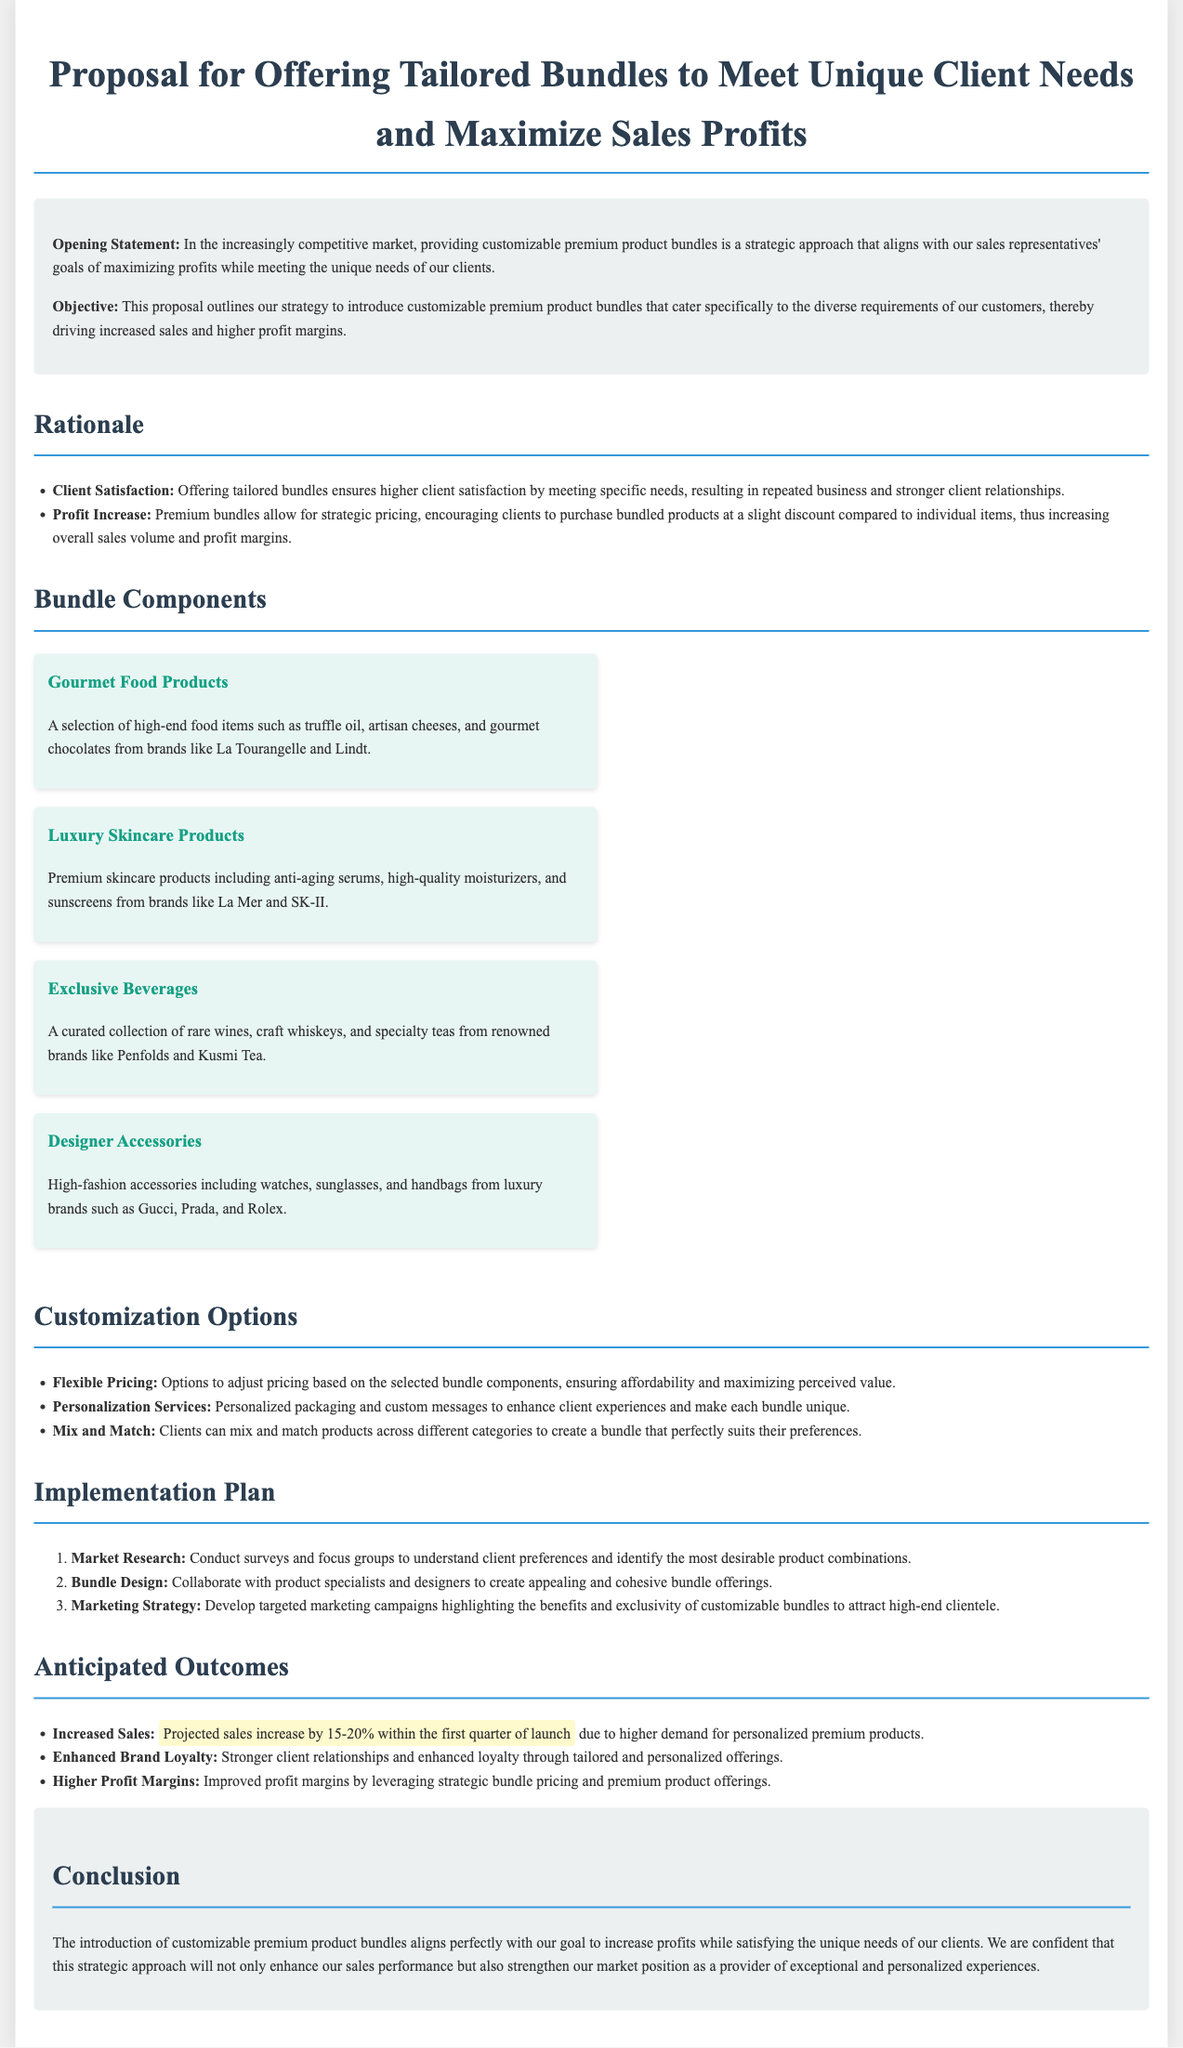What is the title of the proposal? The title of the proposal is located at the top of the document, introducing the subject matter.
Answer: Proposal for Offering Tailored Bundles to Meet Unique Client Needs and Maximize Sales Profits What is the main objective outlined in the proposal? The objective is stated in the introductory section and details the purpose of the proposal.
Answer: Introduce customizable premium product bundles What are two components included in the bundle? The bundle components section lists various items, and two examples can be extracted from that list.
Answer: Gourmet Food Products, Luxury Skincare Products What is the projected sales increase within the first quarter? The anticipated outcomes section specifies the expected percentage increase in sales after launch.
Answer: 15-20% What customization option enhances client experiences? The customization options section describes several ways to tailor the bundles for clients, focusing on enhancing experiences.
Answer: Personalization Services How many steps are in the implementation plan? The implementation plan outlines specific steps that are numbered and listed in the document.
Answer: Three What is a key anticipated outcome regarding brand loyalty? The anticipated outcomes section mentions the relationship between tailored offerings and client loyalty.
Answer: Enhanced Brand Loyalty What is a reason for offering tailored bundles? The rationale section provides specific justifications for creating customizable bundles.
Answer: Client Satisfaction What type of products are included in "Exclusive Beverages"? This component is explicitly defined within the bundle components section.
Answer: Rare wines, craft whiskeys, specialty teas 